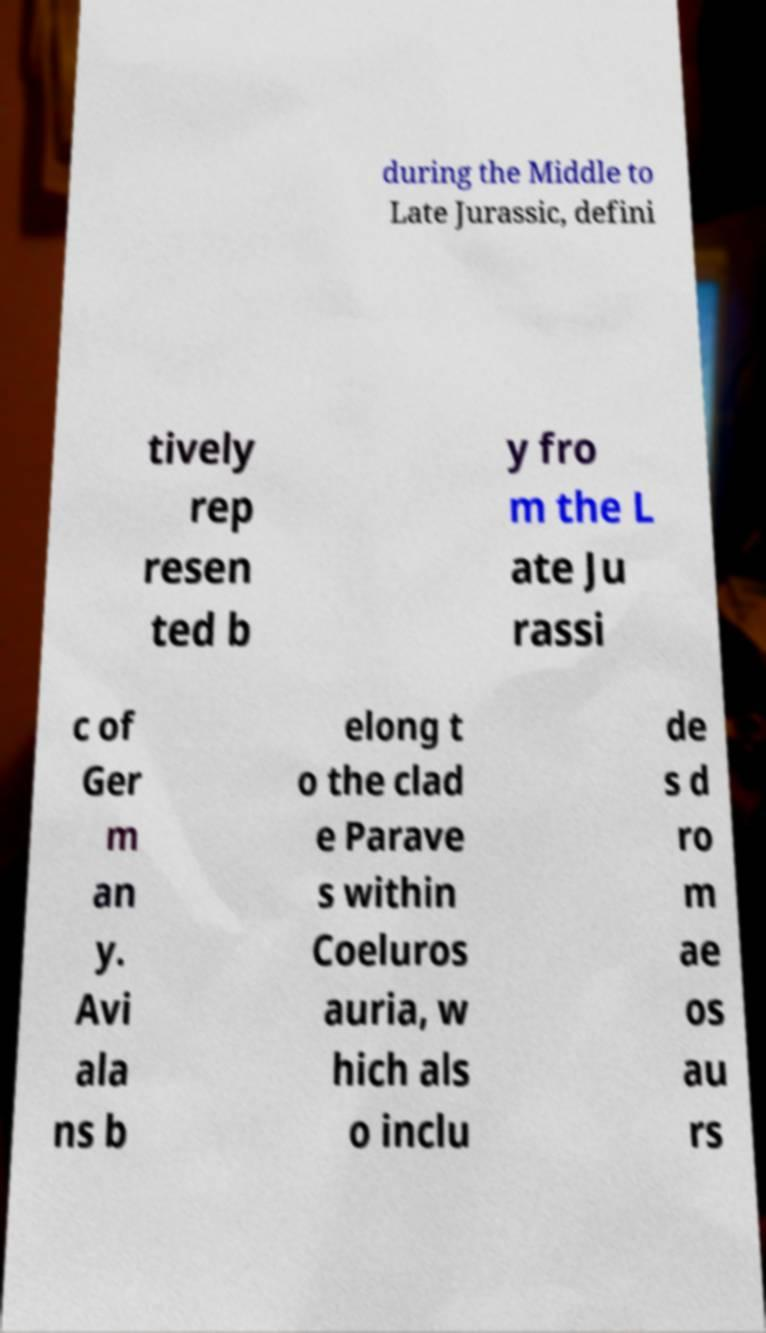Can you read and provide the text displayed in the image?This photo seems to have some interesting text. Can you extract and type it out for me? during the Middle to Late Jurassic, defini tively rep resen ted b y fro m the L ate Ju rassi c of Ger m an y. Avi ala ns b elong t o the clad e Parave s within Coeluros auria, w hich als o inclu de s d ro m ae os au rs 